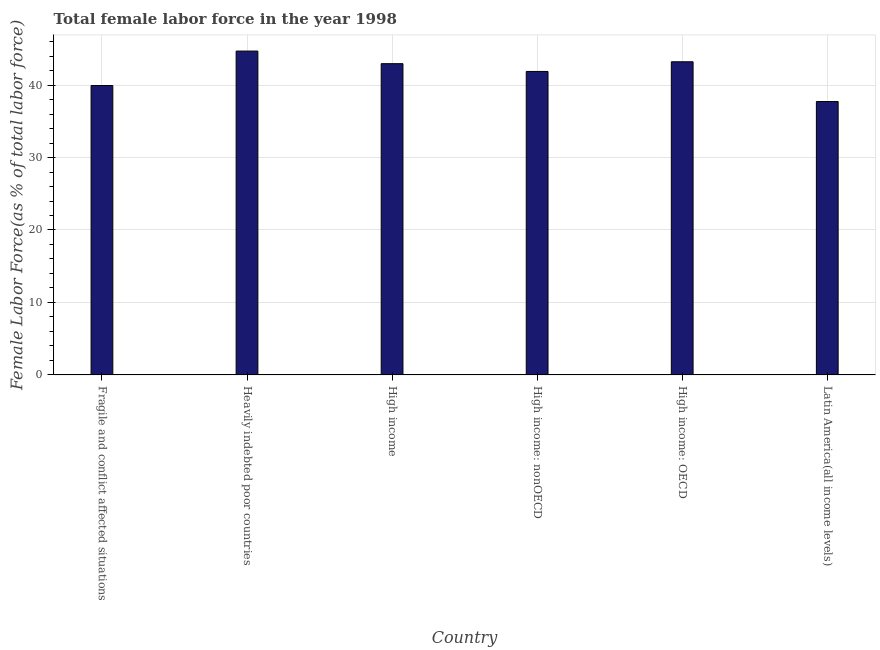What is the title of the graph?
Keep it short and to the point. Total female labor force in the year 1998. What is the label or title of the X-axis?
Provide a short and direct response. Country. What is the label or title of the Y-axis?
Offer a terse response. Female Labor Force(as % of total labor force). What is the total female labor force in Heavily indebted poor countries?
Provide a succinct answer. 44.69. Across all countries, what is the maximum total female labor force?
Provide a succinct answer. 44.69. Across all countries, what is the minimum total female labor force?
Provide a succinct answer. 37.73. In which country was the total female labor force maximum?
Make the answer very short. Heavily indebted poor countries. In which country was the total female labor force minimum?
Your response must be concise. Latin America(all income levels). What is the sum of the total female labor force?
Offer a terse response. 250.41. What is the difference between the total female labor force in High income and Latin America(all income levels)?
Give a very brief answer. 5.22. What is the average total female labor force per country?
Make the answer very short. 41.73. What is the median total female labor force?
Keep it short and to the point. 42.42. What is the ratio of the total female labor force in High income to that in High income: nonOECD?
Give a very brief answer. 1.03. What is the difference between the highest and the second highest total female labor force?
Provide a succinct answer. 1.48. What is the difference between the highest and the lowest total female labor force?
Your answer should be very brief. 6.97. In how many countries, is the total female labor force greater than the average total female labor force taken over all countries?
Provide a succinct answer. 4. Are all the bars in the graph horizontal?
Give a very brief answer. No. What is the Female Labor Force(as % of total labor force) of Fragile and conflict affected situations?
Ensure brevity in your answer.  39.94. What is the Female Labor Force(as % of total labor force) in Heavily indebted poor countries?
Your answer should be very brief. 44.69. What is the Female Labor Force(as % of total labor force) in High income?
Your answer should be compact. 42.95. What is the Female Labor Force(as % of total labor force) of High income: nonOECD?
Provide a short and direct response. 41.88. What is the Female Labor Force(as % of total labor force) of High income: OECD?
Give a very brief answer. 43.22. What is the Female Labor Force(as % of total labor force) in Latin America(all income levels)?
Provide a succinct answer. 37.73. What is the difference between the Female Labor Force(as % of total labor force) in Fragile and conflict affected situations and Heavily indebted poor countries?
Ensure brevity in your answer.  -4.76. What is the difference between the Female Labor Force(as % of total labor force) in Fragile and conflict affected situations and High income?
Offer a terse response. -3.02. What is the difference between the Female Labor Force(as % of total labor force) in Fragile and conflict affected situations and High income: nonOECD?
Your answer should be very brief. -1.94. What is the difference between the Female Labor Force(as % of total labor force) in Fragile and conflict affected situations and High income: OECD?
Offer a very short reply. -3.28. What is the difference between the Female Labor Force(as % of total labor force) in Fragile and conflict affected situations and Latin America(all income levels)?
Your answer should be compact. 2.21. What is the difference between the Female Labor Force(as % of total labor force) in Heavily indebted poor countries and High income?
Your answer should be compact. 1.74. What is the difference between the Female Labor Force(as % of total labor force) in Heavily indebted poor countries and High income: nonOECD?
Offer a terse response. 2.81. What is the difference between the Female Labor Force(as % of total labor force) in Heavily indebted poor countries and High income: OECD?
Give a very brief answer. 1.48. What is the difference between the Female Labor Force(as % of total labor force) in Heavily indebted poor countries and Latin America(all income levels)?
Provide a succinct answer. 6.97. What is the difference between the Female Labor Force(as % of total labor force) in High income and High income: nonOECD?
Provide a short and direct response. 1.07. What is the difference between the Female Labor Force(as % of total labor force) in High income and High income: OECD?
Your answer should be compact. -0.26. What is the difference between the Female Labor Force(as % of total labor force) in High income and Latin America(all income levels)?
Your response must be concise. 5.22. What is the difference between the Female Labor Force(as % of total labor force) in High income: nonOECD and High income: OECD?
Your answer should be very brief. -1.33. What is the difference between the Female Labor Force(as % of total labor force) in High income: nonOECD and Latin America(all income levels)?
Your answer should be compact. 4.15. What is the difference between the Female Labor Force(as % of total labor force) in High income: OECD and Latin America(all income levels)?
Your response must be concise. 5.49. What is the ratio of the Female Labor Force(as % of total labor force) in Fragile and conflict affected situations to that in Heavily indebted poor countries?
Ensure brevity in your answer.  0.89. What is the ratio of the Female Labor Force(as % of total labor force) in Fragile and conflict affected situations to that in High income?
Offer a very short reply. 0.93. What is the ratio of the Female Labor Force(as % of total labor force) in Fragile and conflict affected situations to that in High income: nonOECD?
Give a very brief answer. 0.95. What is the ratio of the Female Labor Force(as % of total labor force) in Fragile and conflict affected situations to that in High income: OECD?
Offer a terse response. 0.92. What is the ratio of the Female Labor Force(as % of total labor force) in Fragile and conflict affected situations to that in Latin America(all income levels)?
Give a very brief answer. 1.06. What is the ratio of the Female Labor Force(as % of total labor force) in Heavily indebted poor countries to that in High income?
Give a very brief answer. 1.04. What is the ratio of the Female Labor Force(as % of total labor force) in Heavily indebted poor countries to that in High income: nonOECD?
Offer a very short reply. 1.07. What is the ratio of the Female Labor Force(as % of total labor force) in Heavily indebted poor countries to that in High income: OECD?
Make the answer very short. 1.03. What is the ratio of the Female Labor Force(as % of total labor force) in Heavily indebted poor countries to that in Latin America(all income levels)?
Offer a terse response. 1.19. What is the ratio of the Female Labor Force(as % of total labor force) in High income to that in High income: nonOECD?
Provide a short and direct response. 1.03. What is the ratio of the Female Labor Force(as % of total labor force) in High income to that in High income: OECD?
Give a very brief answer. 0.99. What is the ratio of the Female Labor Force(as % of total labor force) in High income to that in Latin America(all income levels)?
Offer a terse response. 1.14. What is the ratio of the Female Labor Force(as % of total labor force) in High income: nonOECD to that in High income: OECD?
Provide a succinct answer. 0.97. What is the ratio of the Female Labor Force(as % of total labor force) in High income: nonOECD to that in Latin America(all income levels)?
Provide a short and direct response. 1.11. What is the ratio of the Female Labor Force(as % of total labor force) in High income: OECD to that in Latin America(all income levels)?
Your answer should be very brief. 1.15. 